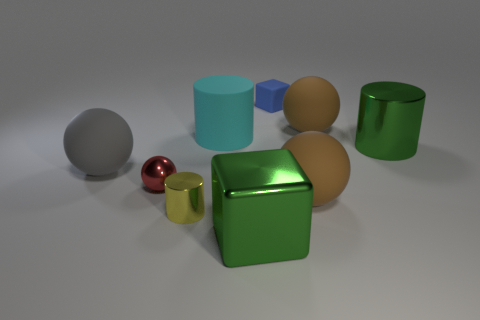How are the objects arranged in relation to one another? The objects are arranged seemingly at random, with no discernible pattern. There's a mixture of different sizes and colors with enough space between each other, avoiding any overlap in the image. 